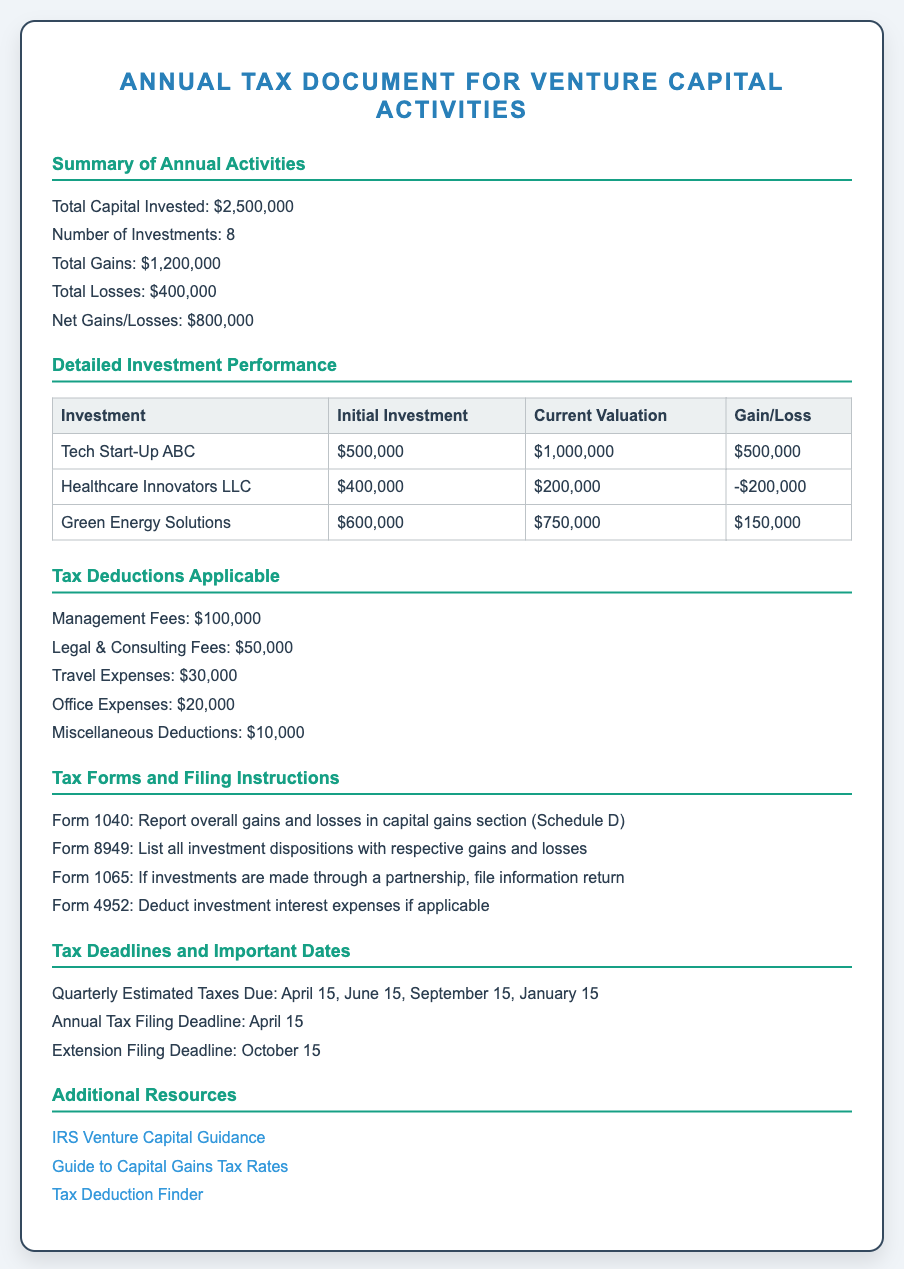What is the total capital invested? The total capital invested is explicitly stated in the document as $2,500,000.
Answer: $2,500,000 Who is the investment in the healthcare sector? The document lists "Healthcare Innovators LLC" as an investment related to healthcare.
Answer: Healthcare Innovators LLC What is the total amount of gains reported? The document specifies the total gains as $1,200,000.
Answer: $1,200,000 What is the net gain/loss amount? The net gains/losses are summarized in the document as $800,000.
Answer: $800,000 How much is claimed for legal and consulting fees? The document states that legal & consulting fees amount to $50,000.
Answer: $50,000 What is the annual tax filing deadline? The annual tax filing deadline is clearly mentioned as April 15.
Answer: April 15 What form is used to report overall gains and losses? The document indicates that Form 1040 is used for this purpose.
Answer: Form 1040 How many investments were made? The document notes that there were a total of 8 investments.
Answer: 8 What is the total of miscellaneous deductions? The total for miscellaneous deductions specified in the document is $10,000.
Answer: $10,000 